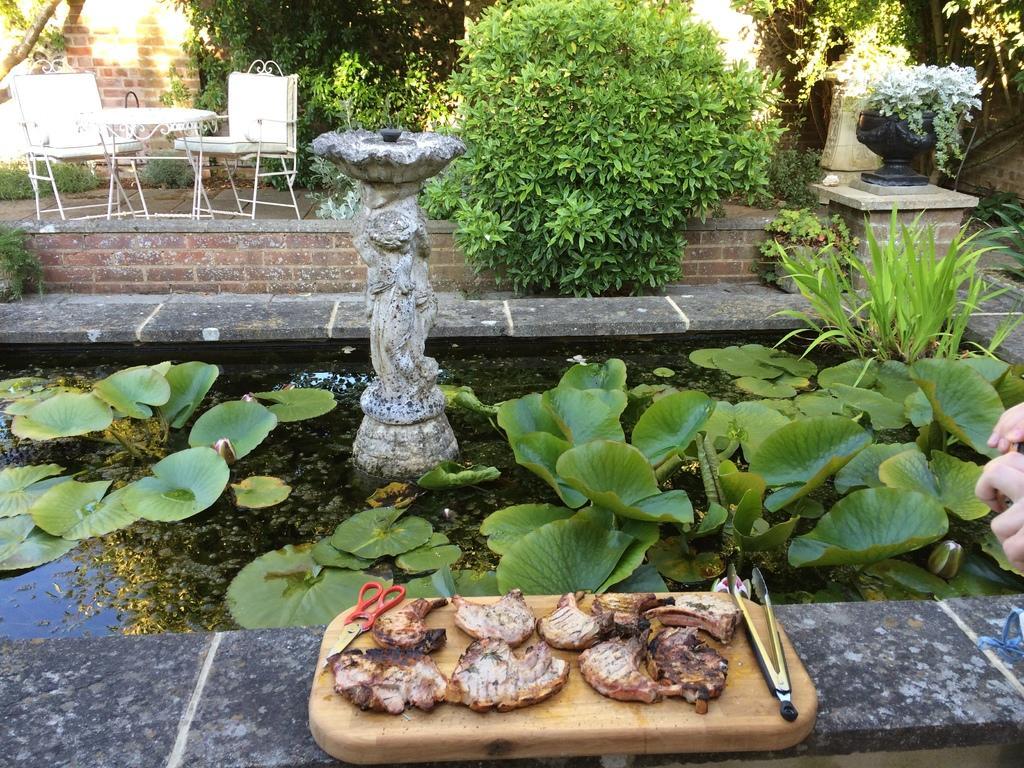How would you summarize this image in a sentence or two? In this picture we can see a chopping board at the bottom, there is some food and scissors present on the chopping board, there is water and some plants in the middle, in the background we can see chairs, a table, a wall and some plants. 